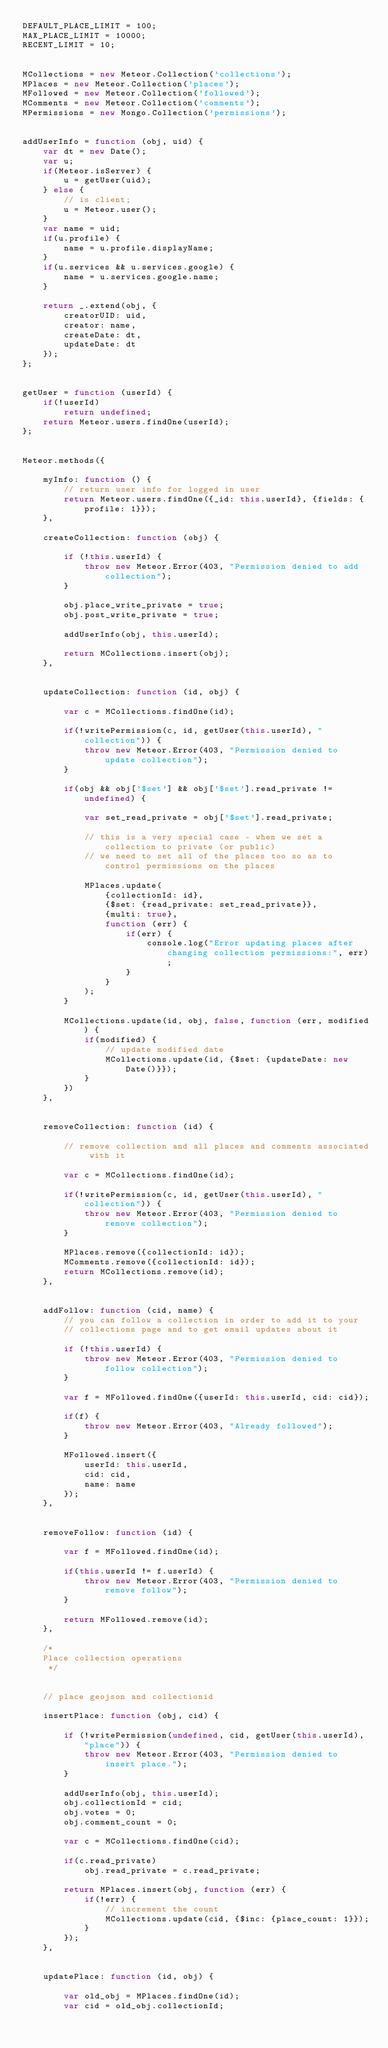<code> <loc_0><loc_0><loc_500><loc_500><_JavaScript_>DEFAULT_PLACE_LIMIT = 100;
MAX_PLACE_LIMIT = 10000;
RECENT_LIMIT = 10;


MCollections = new Meteor.Collection('collections');
MPlaces = new Meteor.Collection('places');
MFollowed = new Meteor.Collection('followed');
MComments = new Meteor.Collection('comments');
MPermissions = new Mongo.Collection('permissions');


addUserInfo = function (obj, uid) {
    var dt = new Date();
    var u;
    if(Meteor.isServer) {
        u = getUser(uid);
    } else {
        // is client;
        u = Meteor.user();
    }
    var name = uid;
    if(u.profile) {
        name = u.profile.displayName;
    }
    if(u.services && u.services.google) {
        name = u.services.google.name;
    }
        
    return _.extend(obj, {
        creatorUID: uid,
        creator: name,
        createDate: dt,
        updateDate: dt
    });
};


getUser = function (userId) {
    if(!userId)
        return undefined;
    return Meteor.users.findOne(userId);
};


Meteor.methods({

    myInfo: function () {
        // return user info for logged in user
        return Meteor.users.findOne({_id: this.userId}, {fields: {profile: 1}});
    },

    createCollection: function (obj) {

        if (!this.userId) {
            throw new Meteor.Error(403, "Permission denied to add collection");
        }

        obj.place_write_private = true;
        obj.post_write_private = true;

        addUserInfo(obj, this.userId);

        return MCollections.insert(obj);
    },


    updateCollection: function (id, obj) {

        var c = MCollections.findOne(id);

        if(!writePermission(c, id, getUser(this.userId), "collection")) {
            throw new Meteor.Error(403, "Permission denied to update collection");
        }

        if(obj && obj['$set'] && obj['$set'].read_private != undefined) {

            var set_read_private = obj['$set'].read_private;

            // this is a very special case - when we set a collection to private (or public)
            // we need to set all of the places too so as to control permissions on the places

            MPlaces.update(
                {collectionId: id},
                {$set: {read_private: set_read_private}},
                {multi: true},
                function (err) {
                    if(err) {
                        console.log("Error updating places after changing collection permissions:", err);
                    }
                }
            );
        }

        MCollections.update(id, obj, false, function (err, modified) {
            if(modified) {
                // update modified date
                MCollections.update(id, {$set: {updateDate: new Date()}});
            }
        })
    },


    removeCollection: function (id) {

        // remove collection and all places and comments associated with it

        var c = MCollections.findOne(id);

        if(!writePermission(c, id, getUser(this.userId), "collection")) {
            throw new Meteor.Error(403, "Permission denied to remove collection");
        }

        MPlaces.remove({collectionId: id});
        MComments.remove({collectionId: id});
        return MCollections.remove(id);
    },


    addFollow: function (cid, name) {
        // you can follow a collection in order to add it to your
        // collections page and to get email updates about it

        if (!this.userId) {
            throw new Meteor.Error(403, "Permission denied to follow collection");
        }

        var f = MFollowed.findOne({userId: this.userId, cid: cid});

        if(f) {
            throw new Meteor.Error(403, "Already followed");
        }

        MFollowed.insert({
            userId: this.userId,
            cid: cid,
            name: name
        });
    },


    removeFollow: function (id) {

        var f = MFollowed.findOne(id);

        if(this.userId != f.userId) {
            throw new Meteor.Error(403, "Permission denied to remove follow");
        }

        return MFollowed.remove(id);
    },

    /*
    Place collection operations
     */


    // place geojson and collectionid

    insertPlace: function (obj, cid) {

        if (!writePermission(undefined, cid, getUser(this.userId), "place")) {
            throw new Meteor.Error(403, "Permission denied to insert place.");
        }

        addUserInfo(obj, this.userId);
        obj.collectionId = cid;
        obj.votes = 0;
        obj.comment_count = 0;

        var c = MCollections.findOne(cid);

        if(c.read_private)
            obj.read_private = c.read_private;

        return MPlaces.insert(obj, function (err) {
            if(!err) {
                // increment the count
                MCollections.update(cid, {$inc: {place_count: 1}});
            }
        });
    },


    updatePlace: function (id, obj) {

        var old_obj = MPlaces.findOne(id);
        var cid = old_obj.collectionId;
</code> 